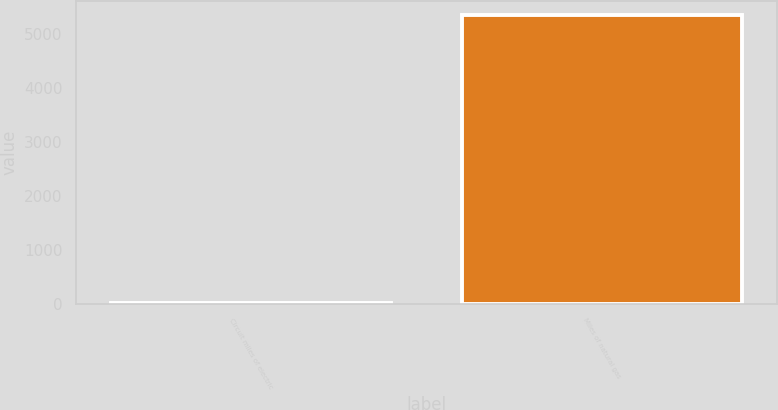Convert chart to OTSL. <chart><loc_0><loc_0><loc_500><loc_500><bar_chart><fcel>Circuit miles of electric<fcel>Miles of natural gas<nl><fcel>11<fcel>5338<nl></chart> 